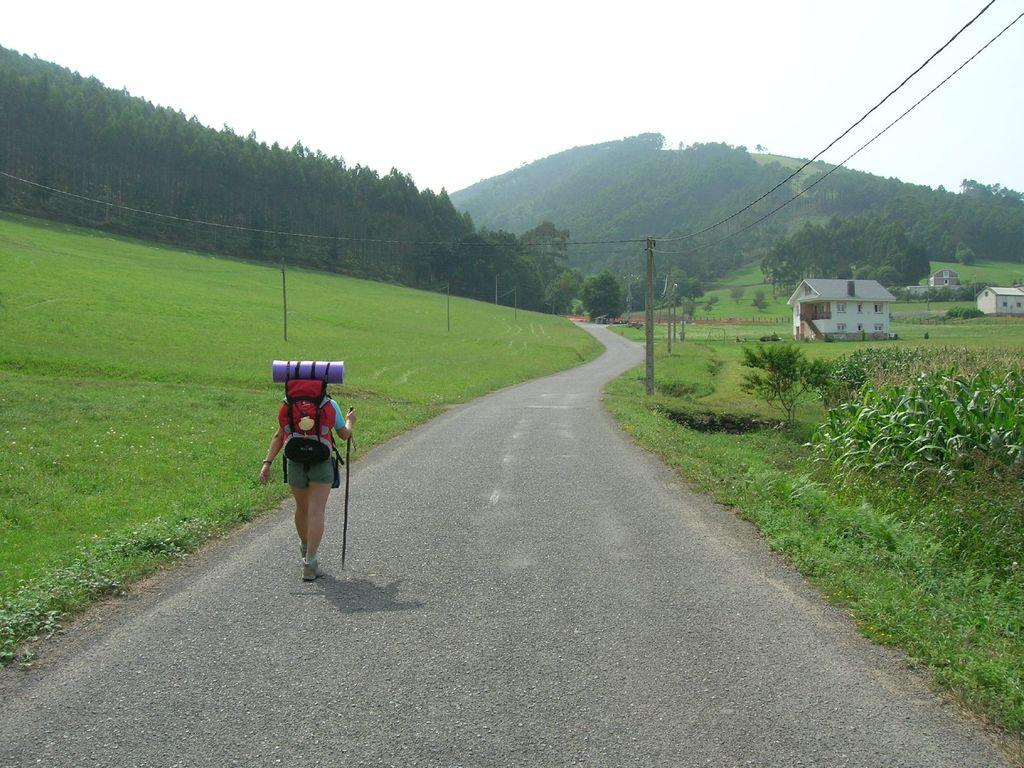What type of natural formation can be seen in the image? There are mountains in the image. What type of vegetation is present in the image? There are trees and small plants in the image. What man-made structures are visible in the image? There are poles, wires, houses, and windows in the image. What is the person in the image doing? The person is walking in the image and is holding a stick. What is the person wearing in the image? The person is wearing bags in the image. What is the color of the sky in the image? The sky is white in color. Where is the person's uncle in the image? There is no mention of an uncle in the image, so it cannot be determined where he might be. What type of shoes is the person wearing in the image? The provided facts do not mention the person's shoes, so it cannot be determined what type they are wearing. 